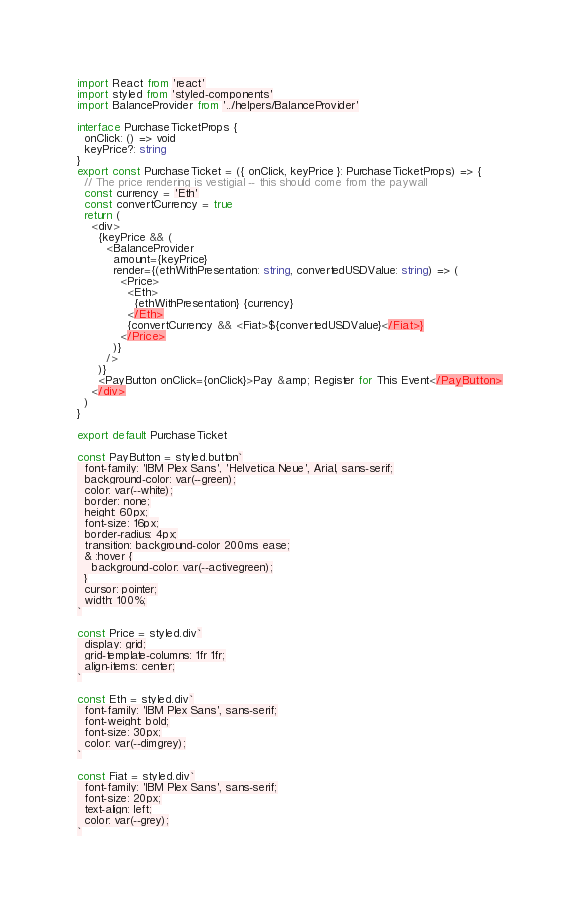<code> <loc_0><loc_0><loc_500><loc_500><_TypeScript_>import React from 'react'
import styled from 'styled-components'
import BalanceProvider from '../helpers/BalanceProvider'

interface PurchaseTicketProps {
  onClick: () => void
  keyPrice?: string
}
export const PurchaseTicket = ({ onClick, keyPrice }: PurchaseTicketProps) => {
  // The price rendering is vestigial -- this should come from the paywall
  const currency = 'Eth'
  const convertCurrency = true
  return (
    <div>
      {keyPrice && (
        <BalanceProvider
          amount={keyPrice}
          render={(ethWithPresentation: string, convertedUSDValue: string) => (
            <Price>
              <Eth>
                {ethWithPresentation} {currency}
              </Eth>
              {convertCurrency && <Fiat>${convertedUSDValue}</Fiat>}
            </Price>
          )}
        />
      )}
      <PayButton onClick={onClick}>Pay &amp; Register for This Event</PayButton>
    </div>
  )
}

export default PurchaseTicket

const PayButton = styled.button`
  font-family: 'IBM Plex Sans', 'Helvetica Neue', Arial, sans-serif;
  background-color: var(--green);
  color: var(--white);
  border: none;
  height: 60px;
  font-size: 16px;
  border-radius: 4px;
  transition: background-color 200ms ease;
  & :hover {
    background-color: var(--activegreen);
  }
  cursor: pointer;
  width: 100%;
`

const Price = styled.div`
  display: grid;
  grid-template-columns: 1fr 1fr;
  align-items: center;
`

const Eth = styled.div`
  font-family: 'IBM Plex Sans', sans-serif;
  font-weight: bold;
  font-size: 30px;
  color: var(--dimgrey);
`

const Fiat = styled.div`
  font-family: 'IBM Plex Sans', sans-serif;
  font-size: 20px;
  text-align: left;
  color: var(--grey);
`
</code> 